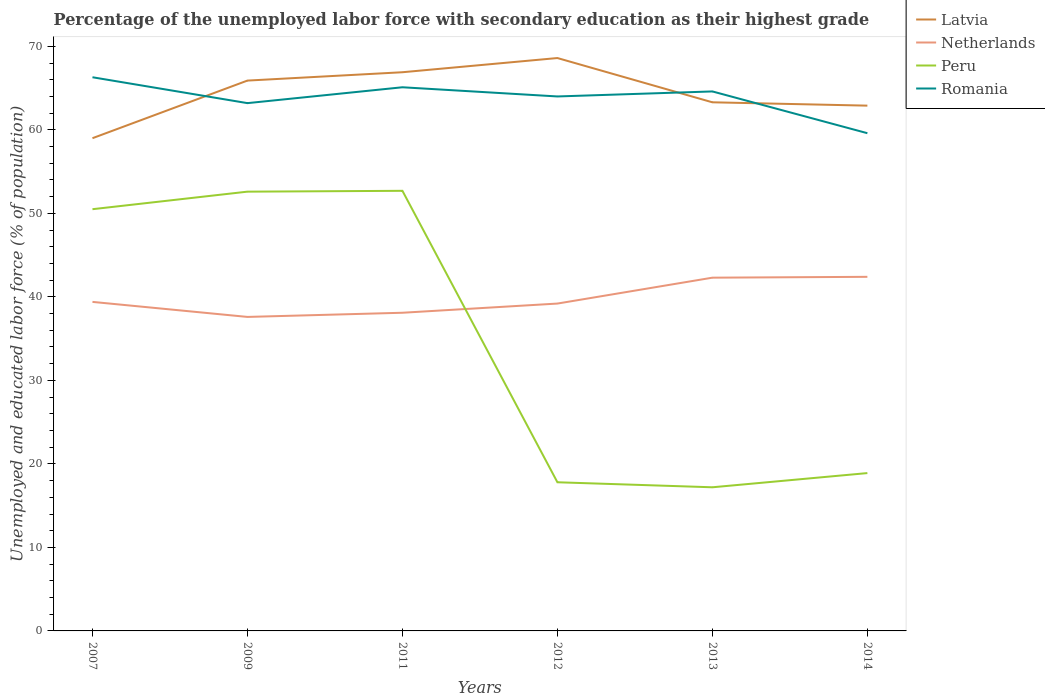Does the line corresponding to Romania intersect with the line corresponding to Netherlands?
Offer a very short reply. No. Across all years, what is the maximum percentage of the unemployed labor force with secondary education in Peru?
Keep it short and to the point. 17.2. What is the total percentage of the unemployed labor force with secondary education in Latvia in the graph?
Ensure brevity in your answer.  -4.3. What is the difference between the highest and the second highest percentage of the unemployed labor force with secondary education in Romania?
Offer a very short reply. 6.7. Is the percentage of the unemployed labor force with secondary education in Latvia strictly greater than the percentage of the unemployed labor force with secondary education in Romania over the years?
Your answer should be very brief. No. What is the difference between two consecutive major ticks on the Y-axis?
Offer a terse response. 10. Does the graph contain any zero values?
Give a very brief answer. No. Does the graph contain grids?
Your response must be concise. No. Where does the legend appear in the graph?
Provide a succinct answer. Top right. How many legend labels are there?
Your answer should be very brief. 4. How are the legend labels stacked?
Provide a short and direct response. Vertical. What is the title of the graph?
Offer a terse response. Percentage of the unemployed labor force with secondary education as their highest grade. What is the label or title of the X-axis?
Your answer should be compact. Years. What is the label or title of the Y-axis?
Offer a terse response. Unemployed and educated labor force (% of population). What is the Unemployed and educated labor force (% of population) in Latvia in 2007?
Make the answer very short. 59. What is the Unemployed and educated labor force (% of population) of Netherlands in 2007?
Your response must be concise. 39.4. What is the Unemployed and educated labor force (% of population) in Peru in 2007?
Offer a very short reply. 50.5. What is the Unemployed and educated labor force (% of population) in Romania in 2007?
Give a very brief answer. 66.3. What is the Unemployed and educated labor force (% of population) of Latvia in 2009?
Provide a short and direct response. 65.9. What is the Unemployed and educated labor force (% of population) of Netherlands in 2009?
Keep it short and to the point. 37.6. What is the Unemployed and educated labor force (% of population) in Peru in 2009?
Keep it short and to the point. 52.6. What is the Unemployed and educated labor force (% of population) of Romania in 2009?
Your response must be concise. 63.2. What is the Unemployed and educated labor force (% of population) of Latvia in 2011?
Offer a very short reply. 66.9. What is the Unemployed and educated labor force (% of population) in Netherlands in 2011?
Your response must be concise. 38.1. What is the Unemployed and educated labor force (% of population) of Peru in 2011?
Your answer should be compact. 52.7. What is the Unemployed and educated labor force (% of population) in Romania in 2011?
Give a very brief answer. 65.1. What is the Unemployed and educated labor force (% of population) of Latvia in 2012?
Provide a short and direct response. 68.6. What is the Unemployed and educated labor force (% of population) in Netherlands in 2012?
Your answer should be compact. 39.2. What is the Unemployed and educated labor force (% of population) of Peru in 2012?
Ensure brevity in your answer.  17.8. What is the Unemployed and educated labor force (% of population) in Romania in 2012?
Provide a succinct answer. 64. What is the Unemployed and educated labor force (% of population) of Latvia in 2013?
Make the answer very short. 63.3. What is the Unemployed and educated labor force (% of population) of Netherlands in 2013?
Make the answer very short. 42.3. What is the Unemployed and educated labor force (% of population) in Peru in 2013?
Ensure brevity in your answer.  17.2. What is the Unemployed and educated labor force (% of population) in Romania in 2013?
Give a very brief answer. 64.6. What is the Unemployed and educated labor force (% of population) of Latvia in 2014?
Your response must be concise. 62.9. What is the Unemployed and educated labor force (% of population) of Netherlands in 2014?
Your response must be concise. 42.4. What is the Unemployed and educated labor force (% of population) of Peru in 2014?
Your response must be concise. 18.9. What is the Unemployed and educated labor force (% of population) of Romania in 2014?
Your response must be concise. 59.6. Across all years, what is the maximum Unemployed and educated labor force (% of population) in Latvia?
Give a very brief answer. 68.6. Across all years, what is the maximum Unemployed and educated labor force (% of population) of Netherlands?
Make the answer very short. 42.4. Across all years, what is the maximum Unemployed and educated labor force (% of population) in Peru?
Ensure brevity in your answer.  52.7. Across all years, what is the maximum Unemployed and educated labor force (% of population) in Romania?
Your answer should be compact. 66.3. Across all years, what is the minimum Unemployed and educated labor force (% of population) in Latvia?
Make the answer very short. 59. Across all years, what is the minimum Unemployed and educated labor force (% of population) of Netherlands?
Provide a succinct answer. 37.6. Across all years, what is the minimum Unemployed and educated labor force (% of population) in Peru?
Keep it short and to the point. 17.2. Across all years, what is the minimum Unemployed and educated labor force (% of population) of Romania?
Your answer should be very brief. 59.6. What is the total Unemployed and educated labor force (% of population) in Latvia in the graph?
Ensure brevity in your answer.  386.6. What is the total Unemployed and educated labor force (% of population) in Netherlands in the graph?
Offer a terse response. 239. What is the total Unemployed and educated labor force (% of population) in Peru in the graph?
Offer a terse response. 209.7. What is the total Unemployed and educated labor force (% of population) in Romania in the graph?
Offer a very short reply. 382.8. What is the difference between the Unemployed and educated labor force (% of population) of Latvia in 2007 and that in 2009?
Give a very brief answer. -6.9. What is the difference between the Unemployed and educated labor force (% of population) of Netherlands in 2007 and that in 2009?
Keep it short and to the point. 1.8. What is the difference between the Unemployed and educated labor force (% of population) of Peru in 2007 and that in 2009?
Give a very brief answer. -2.1. What is the difference between the Unemployed and educated labor force (% of population) of Romania in 2007 and that in 2009?
Provide a succinct answer. 3.1. What is the difference between the Unemployed and educated labor force (% of population) of Latvia in 2007 and that in 2011?
Give a very brief answer. -7.9. What is the difference between the Unemployed and educated labor force (% of population) in Netherlands in 2007 and that in 2011?
Offer a very short reply. 1.3. What is the difference between the Unemployed and educated labor force (% of population) in Peru in 2007 and that in 2011?
Your response must be concise. -2.2. What is the difference between the Unemployed and educated labor force (% of population) in Romania in 2007 and that in 2011?
Your answer should be very brief. 1.2. What is the difference between the Unemployed and educated labor force (% of population) in Netherlands in 2007 and that in 2012?
Your answer should be very brief. 0.2. What is the difference between the Unemployed and educated labor force (% of population) of Peru in 2007 and that in 2012?
Make the answer very short. 32.7. What is the difference between the Unemployed and educated labor force (% of population) of Romania in 2007 and that in 2012?
Your answer should be compact. 2.3. What is the difference between the Unemployed and educated labor force (% of population) in Netherlands in 2007 and that in 2013?
Offer a very short reply. -2.9. What is the difference between the Unemployed and educated labor force (% of population) of Peru in 2007 and that in 2013?
Your answer should be compact. 33.3. What is the difference between the Unemployed and educated labor force (% of population) of Netherlands in 2007 and that in 2014?
Make the answer very short. -3. What is the difference between the Unemployed and educated labor force (% of population) in Peru in 2007 and that in 2014?
Provide a succinct answer. 31.6. What is the difference between the Unemployed and educated labor force (% of population) in Romania in 2007 and that in 2014?
Ensure brevity in your answer.  6.7. What is the difference between the Unemployed and educated labor force (% of population) of Latvia in 2009 and that in 2011?
Offer a terse response. -1. What is the difference between the Unemployed and educated labor force (% of population) in Netherlands in 2009 and that in 2011?
Ensure brevity in your answer.  -0.5. What is the difference between the Unemployed and educated labor force (% of population) in Netherlands in 2009 and that in 2012?
Your response must be concise. -1.6. What is the difference between the Unemployed and educated labor force (% of population) in Peru in 2009 and that in 2012?
Keep it short and to the point. 34.8. What is the difference between the Unemployed and educated labor force (% of population) of Romania in 2009 and that in 2012?
Your answer should be compact. -0.8. What is the difference between the Unemployed and educated labor force (% of population) of Latvia in 2009 and that in 2013?
Offer a very short reply. 2.6. What is the difference between the Unemployed and educated labor force (% of population) of Peru in 2009 and that in 2013?
Ensure brevity in your answer.  35.4. What is the difference between the Unemployed and educated labor force (% of population) of Netherlands in 2009 and that in 2014?
Your response must be concise. -4.8. What is the difference between the Unemployed and educated labor force (% of population) of Peru in 2009 and that in 2014?
Keep it short and to the point. 33.7. What is the difference between the Unemployed and educated labor force (% of population) of Romania in 2009 and that in 2014?
Give a very brief answer. 3.6. What is the difference between the Unemployed and educated labor force (% of population) of Latvia in 2011 and that in 2012?
Give a very brief answer. -1.7. What is the difference between the Unemployed and educated labor force (% of population) of Netherlands in 2011 and that in 2012?
Provide a short and direct response. -1.1. What is the difference between the Unemployed and educated labor force (% of population) of Peru in 2011 and that in 2012?
Provide a short and direct response. 34.9. What is the difference between the Unemployed and educated labor force (% of population) of Netherlands in 2011 and that in 2013?
Give a very brief answer. -4.2. What is the difference between the Unemployed and educated labor force (% of population) of Peru in 2011 and that in 2013?
Your response must be concise. 35.5. What is the difference between the Unemployed and educated labor force (% of population) of Netherlands in 2011 and that in 2014?
Offer a terse response. -4.3. What is the difference between the Unemployed and educated labor force (% of population) of Peru in 2011 and that in 2014?
Offer a very short reply. 33.8. What is the difference between the Unemployed and educated labor force (% of population) in Latvia in 2012 and that in 2013?
Offer a terse response. 5.3. What is the difference between the Unemployed and educated labor force (% of population) of Peru in 2012 and that in 2013?
Your answer should be compact. 0.6. What is the difference between the Unemployed and educated labor force (% of population) in Peru in 2012 and that in 2014?
Provide a short and direct response. -1.1. What is the difference between the Unemployed and educated labor force (% of population) in Romania in 2012 and that in 2014?
Offer a terse response. 4.4. What is the difference between the Unemployed and educated labor force (% of population) in Netherlands in 2013 and that in 2014?
Give a very brief answer. -0.1. What is the difference between the Unemployed and educated labor force (% of population) of Peru in 2013 and that in 2014?
Make the answer very short. -1.7. What is the difference between the Unemployed and educated labor force (% of population) of Latvia in 2007 and the Unemployed and educated labor force (% of population) of Netherlands in 2009?
Your answer should be compact. 21.4. What is the difference between the Unemployed and educated labor force (% of population) in Netherlands in 2007 and the Unemployed and educated labor force (% of population) in Peru in 2009?
Your answer should be very brief. -13.2. What is the difference between the Unemployed and educated labor force (% of population) of Netherlands in 2007 and the Unemployed and educated labor force (% of population) of Romania in 2009?
Your response must be concise. -23.8. What is the difference between the Unemployed and educated labor force (% of population) of Latvia in 2007 and the Unemployed and educated labor force (% of population) of Netherlands in 2011?
Keep it short and to the point. 20.9. What is the difference between the Unemployed and educated labor force (% of population) of Latvia in 2007 and the Unemployed and educated labor force (% of population) of Romania in 2011?
Your answer should be compact. -6.1. What is the difference between the Unemployed and educated labor force (% of population) in Netherlands in 2007 and the Unemployed and educated labor force (% of population) in Romania in 2011?
Offer a very short reply. -25.7. What is the difference between the Unemployed and educated labor force (% of population) in Peru in 2007 and the Unemployed and educated labor force (% of population) in Romania in 2011?
Your answer should be very brief. -14.6. What is the difference between the Unemployed and educated labor force (% of population) of Latvia in 2007 and the Unemployed and educated labor force (% of population) of Netherlands in 2012?
Provide a short and direct response. 19.8. What is the difference between the Unemployed and educated labor force (% of population) in Latvia in 2007 and the Unemployed and educated labor force (% of population) in Peru in 2012?
Ensure brevity in your answer.  41.2. What is the difference between the Unemployed and educated labor force (% of population) in Latvia in 2007 and the Unemployed and educated labor force (% of population) in Romania in 2012?
Offer a very short reply. -5. What is the difference between the Unemployed and educated labor force (% of population) in Netherlands in 2007 and the Unemployed and educated labor force (% of population) in Peru in 2012?
Make the answer very short. 21.6. What is the difference between the Unemployed and educated labor force (% of population) of Netherlands in 2007 and the Unemployed and educated labor force (% of population) of Romania in 2012?
Your answer should be compact. -24.6. What is the difference between the Unemployed and educated labor force (% of population) in Peru in 2007 and the Unemployed and educated labor force (% of population) in Romania in 2012?
Your answer should be very brief. -13.5. What is the difference between the Unemployed and educated labor force (% of population) of Latvia in 2007 and the Unemployed and educated labor force (% of population) of Peru in 2013?
Offer a terse response. 41.8. What is the difference between the Unemployed and educated labor force (% of population) in Netherlands in 2007 and the Unemployed and educated labor force (% of population) in Peru in 2013?
Your answer should be very brief. 22.2. What is the difference between the Unemployed and educated labor force (% of population) of Netherlands in 2007 and the Unemployed and educated labor force (% of population) of Romania in 2013?
Make the answer very short. -25.2. What is the difference between the Unemployed and educated labor force (% of population) of Peru in 2007 and the Unemployed and educated labor force (% of population) of Romania in 2013?
Offer a terse response. -14.1. What is the difference between the Unemployed and educated labor force (% of population) in Latvia in 2007 and the Unemployed and educated labor force (% of population) in Netherlands in 2014?
Your response must be concise. 16.6. What is the difference between the Unemployed and educated labor force (% of population) in Latvia in 2007 and the Unemployed and educated labor force (% of population) in Peru in 2014?
Offer a terse response. 40.1. What is the difference between the Unemployed and educated labor force (% of population) in Latvia in 2007 and the Unemployed and educated labor force (% of population) in Romania in 2014?
Offer a very short reply. -0.6. What is the difference between the Unemployed and educated labor force (% of population) of Netherlands in 2007 and the Unemployed and educated labor force (% of population) of Peru in 2014?
Provide a short and direct response. 20.5. What is the difference between the Unemployed and educated labor force (% of population) in Netherlands in 2007 and the Unemployed and educated labor force (% of population) in Romania in 2014?
Ensure brevity in your answer.  -20.2. What is the difference between the Unemployed and educated labor force (% of population) in Peru in 2007 and the Unemployed and educated labor force (% of population) in Romania in 2014?
Give a very brief answer. -9.1. What is the difference between the Unemployed and educated labor force (% of population) of Latvia in 2009 and the Unemployed and educated labor force (% of population) of Netherlands in 2011?
Make the answer very short. 27.8. What is the difference between the Unemployed and educated labor force (% of population) of Latvia in 2009 and the Unemployed and educated labor force (% of population) of Peru in 2011?
Offer a very short reply. 13.2. What is the difference between the Unemployed and educated labor force (% of population) of Netherlands in 2009 and the Unemployed and educated labor force (% of population) of Peru in 2011?
Offer a very short reply. -15.1. What is the difference between the Unemployed and educated labor force (% of population) in Netherlands in 2009 and the Unemployed and educated labor force (% of population) in Romania in 2011?
Your response must be concise. -27.5. What is the difference between the Unemployed and educated labor force (% of population) of Latvia in 2009 and the Unemployed and educated labor force (% of population) of Netherlands in 2012?
Your answer should be compact. 26.7. What is the difference between the Unemployed and educated labor force (% of population) of Latvia in 2009 and the Unemployed and educated labor force (% of population) of Peru in 2012?
Offer a very short reply. 48.1. What is the difference between the Unemployed and educated labor force (% of population) of Netherlands in 2009 and the Unemployed and educated labor force (% of population) of Peru in 2012?
Offer a very short reply. 19.8. What is the difference between the Unemployed and educated labor force (% of population) of Netherlands in 2009 and the Unemployed and educated labor force (% of population) of Romania in 2012?
Offer a very short reply. -26.4. What is the difference between the Unemployed and educated labor force (% of population) in Latvia in 2009 and the Unemployed and educated labor force (% of population) in Netherlands in 2013?
Offer a very short reply. 23.6. What is the difference between the Unemployed and educated labor force (% of population) of Latvia in 2009 and the Unemployed and educated labor force (% of population) of Peru in 2013?
Your answer should be compact. 48.7. What is the difference between the Unemployed and educated labor force (% of population) in Latvia in 2009 and the Unemployed and educated labor force (% of population) in Romania in 2013?
Offer a terse response. 1.3. What is the difference between the Unemployed and educated labor force (% of population) in Netherlands in 2009 and the Unemployed and educated labor force (% of population) in Peru in 2013?
Offer a very short reply. 20.4. What is the difference between the Unemployed and educated labor force (% of population) of Peru in 2009 and the Unemployed and educated labor force (% of population) of Romania in 2013?
Your answer should be compact. -12. What is the difference between the Unemployed and educated labor force (% of population) of Latvia in 2009 and the Unemployed and educated labor force (% of population) of Peru in 2014?
Ensure brevity in your answer.  47. What is the difference between the Unemployed and educated labor force (% of population) in Netherlands in 2009 and the Unemployed and educated labor force (% of population) in Peru in 2014?
Your answer should be compact. 18.7. What is the difference between the Unemployed and educated labor force (% of population) of Latvia in 2011 and the Unemployed and educated labor force (% of population) of Netherlands in 2012?
Provide a succinct answer. 27.7. What is the difference between the Unemployed and educated labor force (% of population) of Latvia in 2011 and the Unemployed and educated labor force (% of population) of Peru in 2012?
Provide a short and direct response. 49.1. What is the difference between the Unemployed and educated labor force (% of population) in Latvia in 2011 and the Unemployed and educated labor force (% of population) in Romania in 2012?
Your answer should be compact. 2.9. What is the difference between the Unemployed and educated labor force (% of population) of Netherlands in 2011 and the Unemployed and educated labor force (% of population) of Peru in 2012?
Give a very brief answer. 20.3. What is the difference between the Unemployed and educated labor force (% of population) of Netherlands in 2011 and the Unemployed and educated labor force (% of population) of Romania in 2012?
Your answer should be compact. -25.9. What is the difference between the Unemployed and educated labor force (% of population) in Latvia in 2011 and the Unemployed and educated labor force (% of population) in Netherlands in 2013?
Your answer should be very brief. 24.6. What is the difference between the Unemployed and educated labor force (% of population) of Latvia in 2011 and the Unemployed and educated labor force (% of population) of Peru in 2013?
Make the answer very short. 49.7. What is the difference between the Unemployed and educated labor force (% of population) of Latvia in 2011 and the Unemployed and educated labor force (% of population) of Romania in 2013?
Your answer should be compact. 2.3. What is the difference between the Unemployed and educated labor force (% of population) in Netherlands in 2011 and the Unemployed and educated labor force (% of population) in Peru in 2013?
Give a very brief answer. 20.9. What is the difference between the Unemployed and educated labor force (% of population) of Netherlands in 2011 and the Unemployed and educated labor force (% of population) of Romania in 2013?
Offer a very short reply. -26.5. What is the difference between the Unemployed and educated labor force (% of population) in Latvia in 2011 and the Unemployed and educated labor force (% of population) in Netherlands in 2014?
Your response must be concise. 24.5. What is the difference between the Unemployed and educated labor force (% of population) in Netherlands in 2011 and the Unemployed and educated labor force (% of population) in Peru in 2014?
Ensure brevity in your answer.  19.2. What is the difference between the Unemployed and educated labor force (% of population) in Netherlands in 2011 and the Unemployed and educated labor force (% of population) in Romania in 2014?
Give a very brief answer. -21.5. What is the difference between the Unemployed and educated labor force (% of population) in Peru in 2011 and the Unemployed and educated labor force (% of population) in Romania in 2014?
Offer a very short reply. -6.9. What is the difference between the Unemployed and educated labor force (% of population) of Latvia in 2012 and the Unemployed and educated labor force (% of population) of Netherlands in 2013?
Ensure brevity in your answer.  26.3. What is the difference between the Unemployed and educated labor force (% of population) of Latvia in 2012 and the Unemployed and educated labor force (% of population) of Peru in 2013?
Provide a short and direct response. 51.4. What is the difference between the Unemployed and educated labor force (% of population) in Latvia in 2012 and the Unemployed and educated labor force (% of population) in Romania in 2013?
Your answer should be compact. 4. What is the difference between the Unemployed and educated labor force (% of population) in Netherlands in 2012 and the Unemployed and educated labor force (% of population) in Romania in 2013?
Your response must be concise. -25.4. What is the difference between the Unemployed and educated labor force (% of population) in Peru in 2012 and the Unemployed and educated labor force (% of population) in Romania in 2013?
Ensure brevity in your answer.  -46.8. What is the difference between the Unemployed and educated labor force (% of population) of Latvia in 2012 and the Unemployed and educated labor force (% of population) of Netherlands in 2014?
Offer a very short reply. 26.2. What is the difference between the Unemployed and educated labor force (% of population) in Latvia in 2012 and the Unemployed and educated labor force (% of population) in Peru in 2014?
Provide a succinct answer. 49.7. What is the difference between the Unemployed and educated labor force (% of population) of Netherlands in 2012 and the Unemployed and educated labor force (% of population) of Peru in 2014?
Offer a very short reply. 20.3. What is the difference between the Unemployed and educated labor force (% of population) in Netherlands in 2012 and the Unemployed and educated labor force (% of population) in Romania in 2014?
Keep it short and to the point. -20.4. What is the difference between the Unemployed and educated labor force (% of population) in Peru in 2012 and the Unemployed and educated labor force (% of population) in Romania in 2014?
Make the answer very short. -41.8. What is the difference between the Unemployed and educated labor force (% of population) of Latvia in 2013 and the Unemployed and educated labor force (% of population) of Netherlands in 2014?
Your answer should be very brief. 20.9. What is the difference between the Unemployed and educated labor force (% of population) of Latvia in 2013 and the Unemployed and educated labor force (% of population) of Peru in 2014?
Offer a very short reply. 44.4. What is the difference between the Unemployed and educated labor force (% of population) in Latvia in 2013 and the Unemployed and educated labor force (% of population) in Romania in 2014?
Give a very brief answer. 3.7. What is the difference between the Unemployed and educated labor force (% of population) of Netherlands in 2013 and the Unemployed and educated labor force (% of population) of Peru in 2014?
Offer a terse response. 23.4. What is the difference between the Unemployed and educated labor force (% of population) of Netherlands in 2013 and the Unemployed and educated labor force (% of population) of Romania in 2014?
Keep it short and to the point. -17.3. What is the difference between the Unemployed and educated labor force (% of population) of Peru in 2013 and the Unemployed and educated labor force (% of population) of Romania in 2014?
Provide a short and direct response. -42.4. What is the average Unemployed and educated labor force (% of population) in Latvia per year?
Make the answer very short. 64.43. What is the average Unemployed and educated labor force (% of population) in Netherlands per year?
Give a very brief answer. 39.83. What is the average Unemployed and educated labor force (% of population) of Peru per year?
Your response must be concise. 34.95. What is the average Unemployed and educated labor force (% of population) in Romania per year?
Your answer should be compact. 63.8. In the year 2007, what is the difference between the Unemployed and educated labor force (% of population) in Latvia and Unemployed and educated labor force (% of population) in Netherlands?
Your answer should be very brief. 19.6. In the year 2007, what is the difference between the Unemployed and educated labor force (% of population) of Latvia and Unemployed and educated labor force (% of population) of Peru?
Provide a succinct answer. 8.5. In the year 2007, what is the difference between the Unemployed and educated labor force (% of population) in Latvia and Unemployed and educated labor force (% of population) in Romania?
Provide a short and direct response. -7.3. In the year 2007, what is the difference between the Unemployed and educated labor force (% of population) in Netherlands and Unemployed and educated labor force (% of population) in Peru?
Offer a terse response. -11.1. In the year 2007, what is the difference between the Unemployed and educated labor force (% of population) in Netherlands and Unemployed and educated labor force (% of population) in Romania?
Offer a terse response. -26.9. In the year 2007, what is the difference between the Unemployed and educated labor force (% of population) in Peru and Unemployed and educated labor force (% of population) in Romania?
Ensure brevity in your answer.  -15.8. In the year 2009, what is the difference between the Unemployed and educated labor force (% of population) in Latvia and Unemployed and educated labor force (% of population) in Netherlands?
Give a very brief answer. 28.3. In the year 2009, what is the difference between the Unemployed and educated labor force (% of population) of Latvia and Unemployed and educated labor force (% of population) of Romania?
Provide a short and direct response. 2.7. In the year 2009, what is the difference between the Unemployed and educated labor force (% of population) in Netherlands and Unemployed and educated labor force (% of population) in Peru?
Make the answer very short. -15. In the year 2009, what is the difference between the Unemployed and educated labor force (% of population) in Netherlands and Unemployed and educated labor force (% of population) in Romania?
Your answer should be very brief. -25.6. In the year 2009, what is the difference between the Unemployed and educated labor force (% of population) in Peru and Unemployed and educated labor force (% of population) in Romania?
Ensure brevity in your answer.  -10.6. In the year 2011, what is the difference between the Unemployed and educated labor force (% of population) of Latvia and Unemployed and educated labor force (% of population) of Netherlands?
Offer a very short reply. 28.8. In the year 2011, what is the difference between the Unemployed and educated labor force (% of population) in Netherlands and Unemployed and educated labor force (% of population) in Peru?
Keep it short and to the point. -14.6. In the year 2011, what is the difference between the Unemployed and educated labor force (% of population) of Netherlands and Unemployed and educated labor force (% of population) of Romania?
Your response must be concise. -27. In the year 2012, what is the difference between the Unemployed and educated labor force (% of population) of Latvia and Unemployed and educated labor force (% of population) of Netherlands?
Your answer should be compact. 29.4. In the year 2012, what is the difference between the Unemployed and educated labor force (% of population) of Latvia and Unemployed and educated labor force (% of population) of Peru?
Your answer should be compact. 50.8. In the year 2012, what is the difference between the Unemployed and educated labor force (% of population) in Latvia and Unemployed and educated labor force (% of population) in Romania?
Offer a very short reply. 4.6. In the year 2012, what is the difference between the Unemployed and educated labor force (% of population) in Netherlands and Unemployed and educated labor force (% of population) in Peru?
Your answer should be compact. 21.4. In the year 2012, what is the difference between the Unemployed and educated labor force (% of population) in Netherlands and Unemployed and educated labor force (% of population) in Romania?
Your response must be concise. -24.8. In the year 2012, what is the difference between the Unemployed and educated labor force (% of population) in Peru and Unemployed and educated labor force (% of population) in Romania?
Provide a succinct answer. -46.2. In the year 2013, what is the difference between the Unemployed and educated labor force (% of population) in Latvia and Unemployed and educated labor force (% of population) in Peru?
Offer a very short reply. 46.1. In the year 2013, what is the difference between the Unemployed and educated labor force (% of population) in Netherlands and Unemployed and educated labor force (% of population) in Peru?
Make the answer very short. 25.1. In the year 2013, what is the difference between the Unemployed and educated labor force (% of population) in Netherlands and Unemployed and educated labor force (% of population) in Romania?
Offer a very short reply. -22.3. In the year 2013, what is the difference between the Unemployed and educated labor force (% of population) in Peru and Unemployed and educated labor force (% of population) in Romania?
Your response must be concise. -47.4. In the year 2014, what is the difference between the Unemployed and educated labor force (% of population) of Latvia and Unemployed and educated labor force (% of population) of Romania?
Give a very brief answer. 3.3. In the year 2014, what is the difference between the Unemployed and educated labor force (% of population) in Netherlands and Unemployed and educated labor force (% of population) in Romania?
Your response must be concise. -17.2. In the year 2014, what is the difference between the Unemployed and educated labor force (% of population) of Peru and Unemployed and educated labor force (% of population) of Romania?
Offer a very short reply. -40.7. What is the ratio of the Unemployed and educated labor force (% of population) of Latvia in 2007 to that in 2009?
Give a very brief answer. 0.9. What is the ratio of the Unemployed and educated labor force (% of population) of Netherlands in 2007 to that in 2009?
Provide a succinct answer. 1.05. What is the ratio of the Unemployed and educated labor force (% of population) in Peru in 2007 to that in 2009?
Give a very brief answer. 0.96. What is the ratio of the Unemployed and educated labor force (% of population) of Romania in 2007 to that in 2009?
Give a very brief answer. 1.05. What is the ratio of the Unemployed and educated labor force (% of population) in Latvia in 2007 to that in 2011?
Your answer should be compact. 0.88. What is the ratio of the Unemployed and educated labor force (% of population) of Netherlands in 2007 to that in 2011?
Your answer should be very brief. 1.03. What is the ratio of the Unemployed and educated labor force (% of population) of Romania in 2007 to that in 2011?
Your answer should be compact. 1.02. What is the ratio of the Unemployed and educated labor force (% of population) in Latvia in 2007 to that in 2012?
Offer a very short reply. 0.86. What is the ratio of the Unemployed and educated labor force (% of population) of Peru in 2007 to that in 2012?
Provide a succinct answer. 2.84. What is the ratio of the Unemployed and educated labor force (% of population) in Romania in 2007 to that in 2012?
Keep it short and to the point. 1.04. What is the ratio of the Unemployed and educated labor force (% of population) of Latvia in 2007 to that in 2013?
Give a very brief answer. 0.93. What is the ratio of the Unemployed and educated labor force (% of population) in Netherlands in 2007 to that in 2013?
Your answer should be compact. 0.93. What is the ratio of the Unemployed and educated labor force (% of population) in Peru in 2007 to that in 2013?
Your answer should be very brief. 2.94. What is the ratio of the Unemployed and educated labor force (% of population) of Romania in 2007 to that in 2013?
Provide a succinct answer. 1.03. What is the ratio of the Unemployed and educated labor force (% of population) of Latvia in 2007 to that in 2014?
Provide a short and direct response. 0.94. What is the ratio of the Unemployed and educated labor force (% of population) of Netherlands in 2007 to that in 2014?
Ensure brevity in your answer.  0.93. What is the ratio of the Unemployed and educated labor force (% of population) of Peru in 2007 to that in 2014?
Your answer should be compact. 2.67. What is the ratio of the Unemployed and educated labor force (% of population) in Romania in 2007 to that in 2014?
Offer a terse response. 1.11. What is the ratio of the Unemployed and educated labor force (% of population) of Latvia in 2009 to that in 2011?
Keep it short and to the point. 0.99. What is the ratio of the Unemployed and educated labor force (% of population) of Netherlands in 2009 to that in 2011?
Make the answer very short. 0.99. What is the ratio of the Unemployed and educated labor force (% of population) of Romania in 2009 to that in 2011?
Provide a short and direct response. 0.97. What is the ratio of the Unemployed and educated labor force (% of population) of Latvia in 2009 to that in 2012?
Ensure brevity in your answer.  0.96. What is the ratio of the Unemployed and educated labor force (% of population) of Netherlands in 2009 to that in 2012?
Offer a terse response. 0.96. What is the ratio of the Unemployed and educated labor force (% of population) in Peru in 2009 to that in 2012?
Offer a very short reply. 2.96. What is the ratio of the Unemployed and educated labor force (% of population) of Romania in 2009 to that in 2012?
Give a very brief answer. 0.99. What is the ratio of the Unemployed and educated labor force (% of population) of Latvia in 2009 to that in 2013?
Provide a succinct answer. 1.04. What is the ratio of the Unemployed and educated labor force (% of population) of Netherlands in 2009 to that in 2013?
Ensure brevity in your answer.  0.89. What is the ratio of the Unemployed and educated labor force (% of population) in Peru in 2009 to that in 2013?
Ensure brevity in your answer.  3.06. What is the ratio of the Unemployed and educated labor force (% of population) in Romania in 2009 to that in 2013?
Offer a terse response. 0.98. What is the ratio of the Unemployed and educated labor force (% of population) of Latvia in 2009 to that in 2014?
Ensure brevity in your answer.  1.05. What is the ratio of the Unemployed and educated labor force (% of population) of Netherlands in 2009 to that in 2014?
Provide a short and direct response. 0.89. What is the ratio of the Unemployed and educated labor force (% of population) in Peru in 2009 to that in 2014?
Give a very brief answer. 2.78. What is the ratio of the Unemployed and educated labor force (% of population) in Romania in 2009 to that in 2014?
Your answer should be compact. 1.06. What is the ratio of the Unemployed and educated labor force (% of population) in Latvia in 2011 to that in 2012?
Provide a succinct answer. 0.98. What is the ratio of the Unemployed and educated labor force (% of population) of Netherlands in 2011 to that in 2012?
Keep it short and to the point. 0.97. What is the ratio of the Unemployed and educated labor force (% of population) of Peru in 2011 to that in 2012?
Make the answer very short. 2.96. What is the ratio of the Unemployed and educated labor force (% of population) of Romania in 2011 to that in 2012?
Make the answer very short. 1.02. What is the ratio of the Unemployed and educated labor force (% of population) of Latvia in 2011 to that in 2013?
Offer a terse response. 1.06. What is the ratio of the Unemployed and educated labor force (% of population) in Netherlands in 2011 to that in 2013?
Offer a very short reply. 0.9. What is the ratio of the Unemployed and educated labor force (% of population) of Peru in 2011 to that in 2013?
Your response must be concise. 3.06. What is the ratio of the Unemployed and educated labor force (% of population) in Romania in 2011 to that in 2013?
Your answer should be very brief. 1.01. What is the ratio of the Unemployed and educated labor force (% of population) of Latvia in 2011 to that in 2014?
Keep it short and to the point. 1.06. What is the ratio of the Unemployed and educated labor force (% of population) in Netherlands in 2011 to that in 2014?
Make the answer very short. 0.9. What is the ratio of the Unemployed and educated labor force (% of population) in Peru in 2011 to that in 2014?
Provide a short and direct response. 2.79. What is the ratio of the Unemployed and educated labor force (% of population) of Romania in 2011 to that in 2014?
Ensure brevity in your answer.  1.09. What is the ratio of the Unemployed and educated labor force (% of population) in Latvia in 2012 to that in 2013?
Your answer should be very brief. 1.08. What is the ratio of the Unemployed and educated labor force (% of population) of Netherlands in 2012 to that in 2013?
Your answer should be compact. 0.93. What is the ratio of the Unemployed and educated labor force (% of population) of Peru in 2012 to that in 2013?
Provide a succinct answer. 1.03. What is the ratio of the Unemployed and educated labor force (% of population) in Latvia in 2012 to that in 2014?
Your answer should be compact. 1.09. What is the ratio of the Unemployed and educated labor force (% of population) in Netherlands in 2012 to that in 2014?
Your answer should be very brief. 0.92. What is the ratio of the Unemployed and educated labor force (% of population) in Peru in 2012 to that in 2014?
Give a very brief answer. 0.94. What is the ratio of the Unemployed and educated labor force (% of population) of Romania in 2012 to that in 2014?
Your response must be concise. 1.07. What is the ratio of the Unemployed and educated labor force (% of population) of Latvia in 2013 to that in 2014?
Ensure brevity in your answer.  1.01. What is the ratio of the Unemployed and educated labor force (% of population) in Netherlands in 2013 to that in 2014?
Provide a succinct answer. 1. What is the ratio of the Unemployed and educated labor force (% of population) of Peru in 2013 to that in 2014?
Ensure brevity in your answer.  0.91. What is the ratio of the Unemployed and educated labor force (% of population) of Romania in 2013 to that in 2014?
Make the answer very short. 1.08. What is the difference between the highest and the second highest Unemployed and educated labor force (% of population) in Netherlands?
Your answer should be very brief. 0.1. What is the difference between the highest and the second highest Unemployed and educated labor force (% of population) of Peru?
Your answer should be compact. 0.1. What is the difference between the highest and the lowest Unemployed and educated labor force (% of population) in Peru?
Keep it short and to the point. 35.5. 